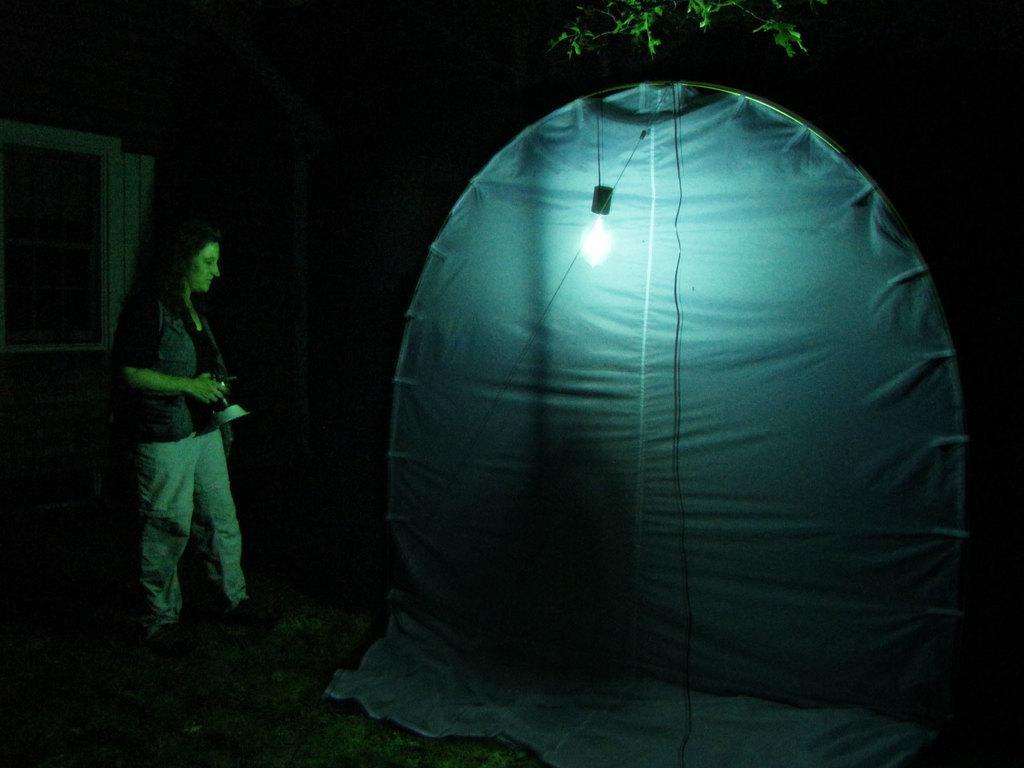How would you summarize this image in a sentence or two? In this image we can see a woman standing and holding an object in her hands, there is a tent in front of the woman and a light inside the tent. 